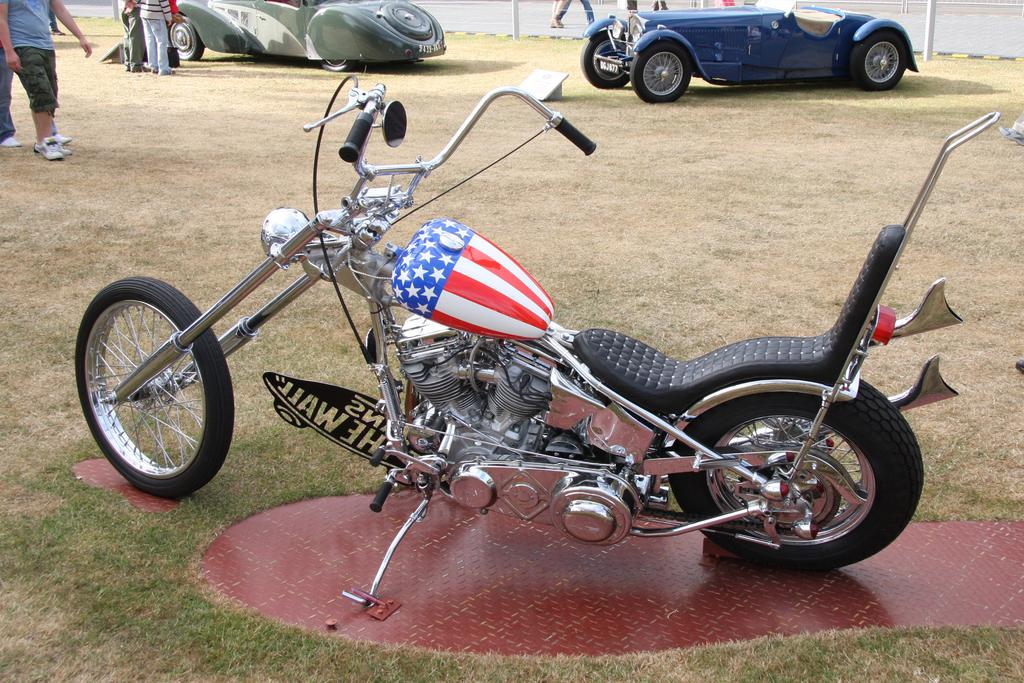What types of objects are present in the image? There are vehicles, people, and poles in the image. What can be seen on the ground in the image? The ground is visible in the image, and there is grass present. Can you describe the setting of the image? The image appears to be outdoors, given the presence of grass and vehicles. What color is the feather that is floating above the vehicles in the image? There is no feather present in the image; it only contains vehicles, people, and poles. 